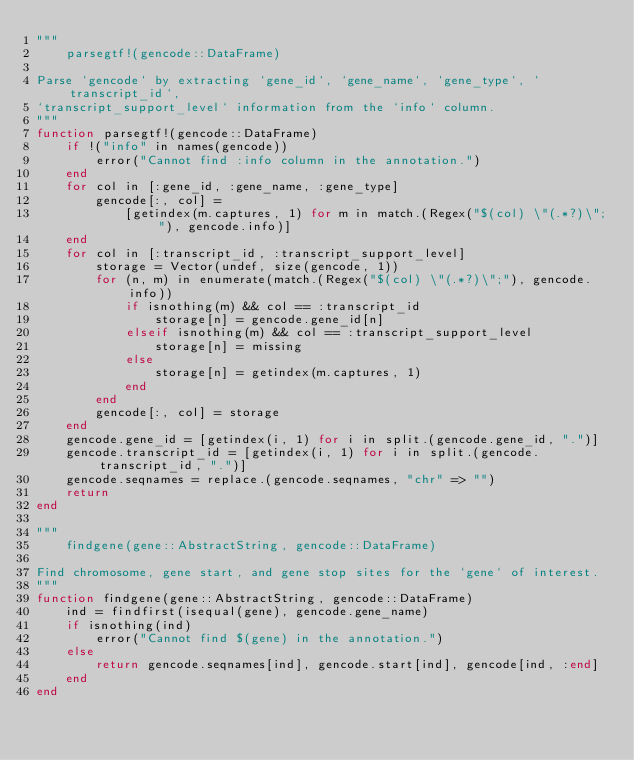<code> <loc_0><loc_0><loc_500><loc_500><_Julia_>"""
    parsegtf!(gencode::DataFrame)

Parse `gencode` by extracting `gene_id`, `gene_name`, `gene_type`, `transcript_id`,
`transcript_support_level` information from the `info` column.
"""
function parsegtf!(gencode::DataFrame)
    if !("info" in names(gencode))
        error("Cannot find :info column in the annotation.")
    end
    for col in [:gene_id, :gene_name, :gene_type]
        gencode[:, col] =
            [getindex(m.captures, 1) for m in match.(Regex("$(col) \"(.*?)\";"), gencode.info)]
    end
    for col in [:transcript_id, :transcript_support_level]
        storage = Vector(undef, size(gencode, 1))
        for (n, m) in enumerate(match.(Regex("$(col) \"(.*?)\";"), gencode.info))
            if isnothing(m) && col == :transcript_id
                storage[n] = gencode.gene_id[n]
            elseif isnothing(m) && col == :transcript_support_level
                storage[n] = missing
            else
                storage[n] = getindex(m.captures, 1)
            end
        end
        gencode[:, col] = storage
    end
    gencode.gene_id = [getindex(i, 1) for i in split.(gencode.gene_id, ".")]
    gencode.transcript_id = [getindex(i, 1) for i in split.(gencode.transcript_id, ".")]
    gencode.seqnames = replace.(gencode.seqnames, "chr" => "")
    return
end

"""
    findgene(gene::AbstractString, gencode::DataFrame)

Find chromosome, gene start, and gene stop sites for the `gene` of interest.
"""
function findgene(gene::AbstractString, gencode::DataFrame)
    ind = findfirst(isequal(gene), gencode.gene_name)
    if isnothing(ind)
        error("Cannot find $(gene) in the annotation.")
    else
        return gencode.seqnames[ind], gencode.start[ind], gencode[ind, :end]
    end
end</code> 